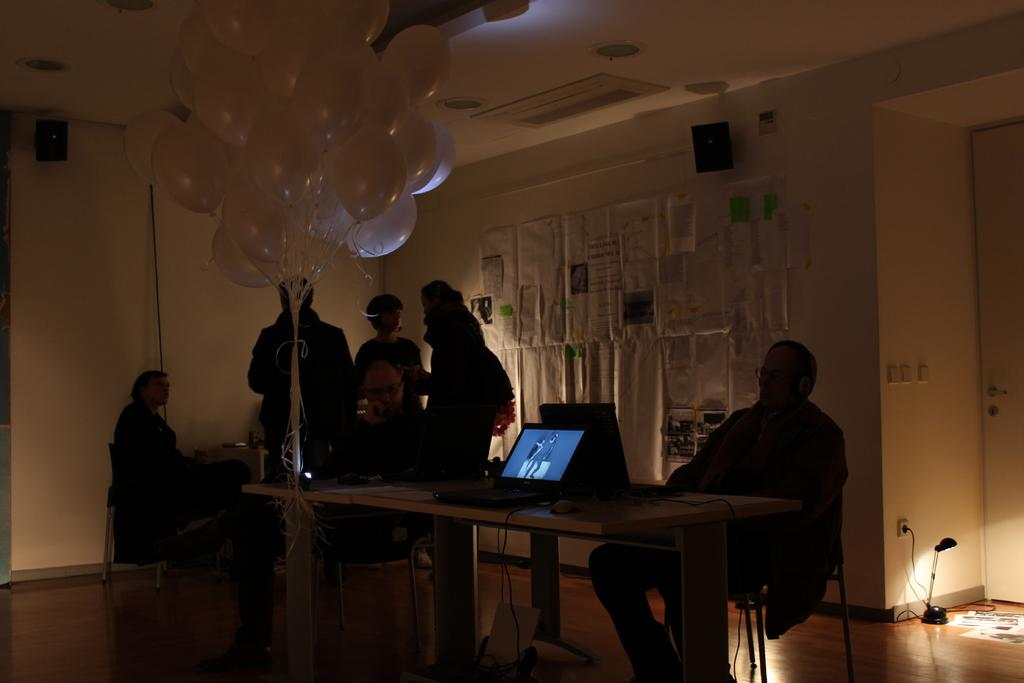What are the people in the image doing? The people in the image are sitting on chairs. Are there any other people visible in the image? Yes, there are people standing in the background of the image. What decorations can be seen in the image? There are many balloons in the image. How are the balloons arranged or secured? The balloons are tied to a table. What type of sign is being displayed by the people in the image? There is no sign being displayed by the people in the image. What invention is being used by the people in the image? The image does not depict any specific invention being used by the people. 